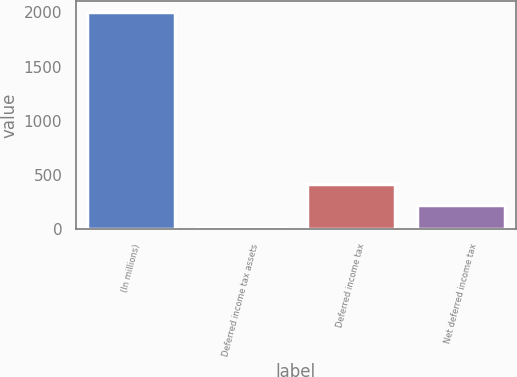Convert chart to OTSL. <chart><loc_0><loc_0><loc_500><loc_500><bar_chart><fcel>(In millions)<fcel>Deferred income tax assets<fcel>Deferred income tax<fcel>Net deferred income tax<nl><fcel>2001<fcel>26.4<fcel>421.32<fcel>223.86<nl></chart> 